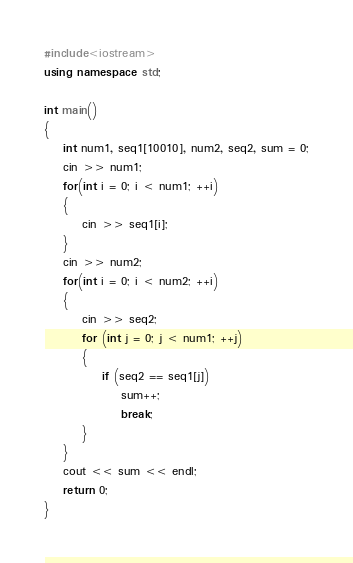<code> <loc_0><loc_0><loc_500><loc_500><_C++_>#include<iostream>
using namespace std;

int main()
{
    int num1, seq1[10010], num2, seq2, sum = 0;
    cin >> num1;
    for(int i = 0; i < num1; ++i)
    {
        cin >> seq1[i];
    }
    cin >> num2;
    for(int i = 0; i < num2; ++i)
    {
        cin >> seq2;
        for (int j = 0; j < num1; ++j)
        {
            if (seq2 == seq1[j])
                sum++;
                break;
        }
    }
    cout << sum << endl;
    return 0;
}</code> 